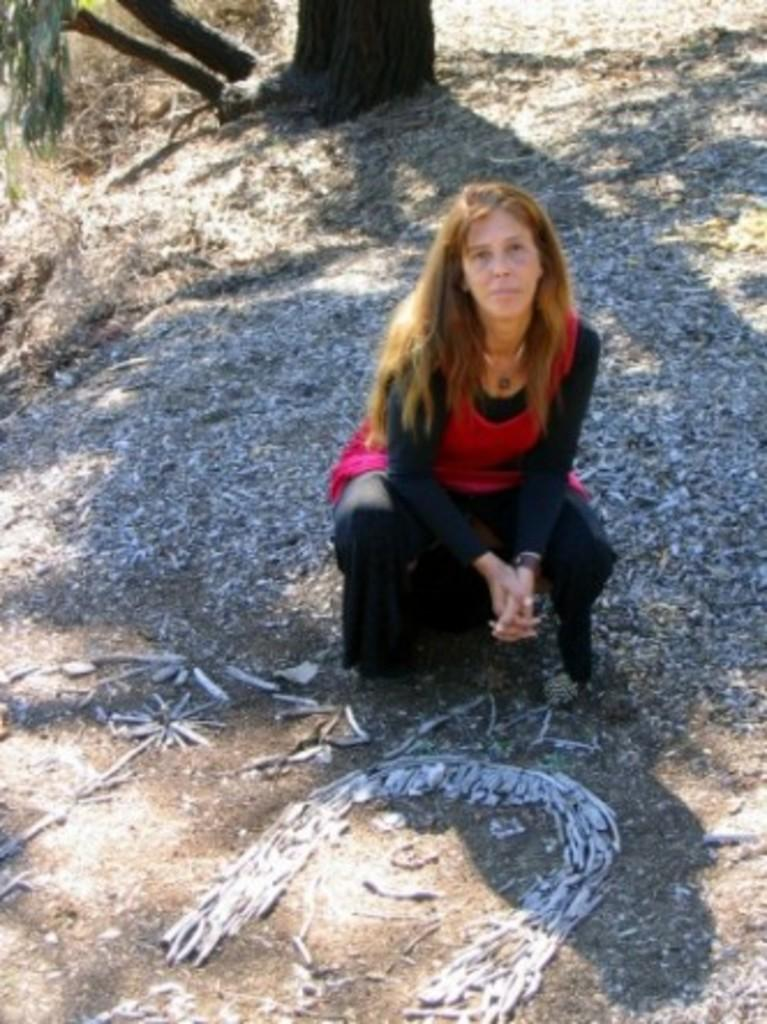Who is the main subject in the image? There is a woman in the image. What is the color of the woman's hair? The woman has brown hair. Where is the woman sitting in the image? The woman is sitting on mud land. What is the woman wearing in the image? The woman is wearing a pink and black dress. What can be seen in the background of the image? There is a tree visible in the background of the image. What type of sack is the woman carrying in the image? There is no sack visible in the image; the woman is not carrying anything. What is the woman's role as a governor in the image? The woman is not depicted as a governor in the image; there is no indication of her role or position. 